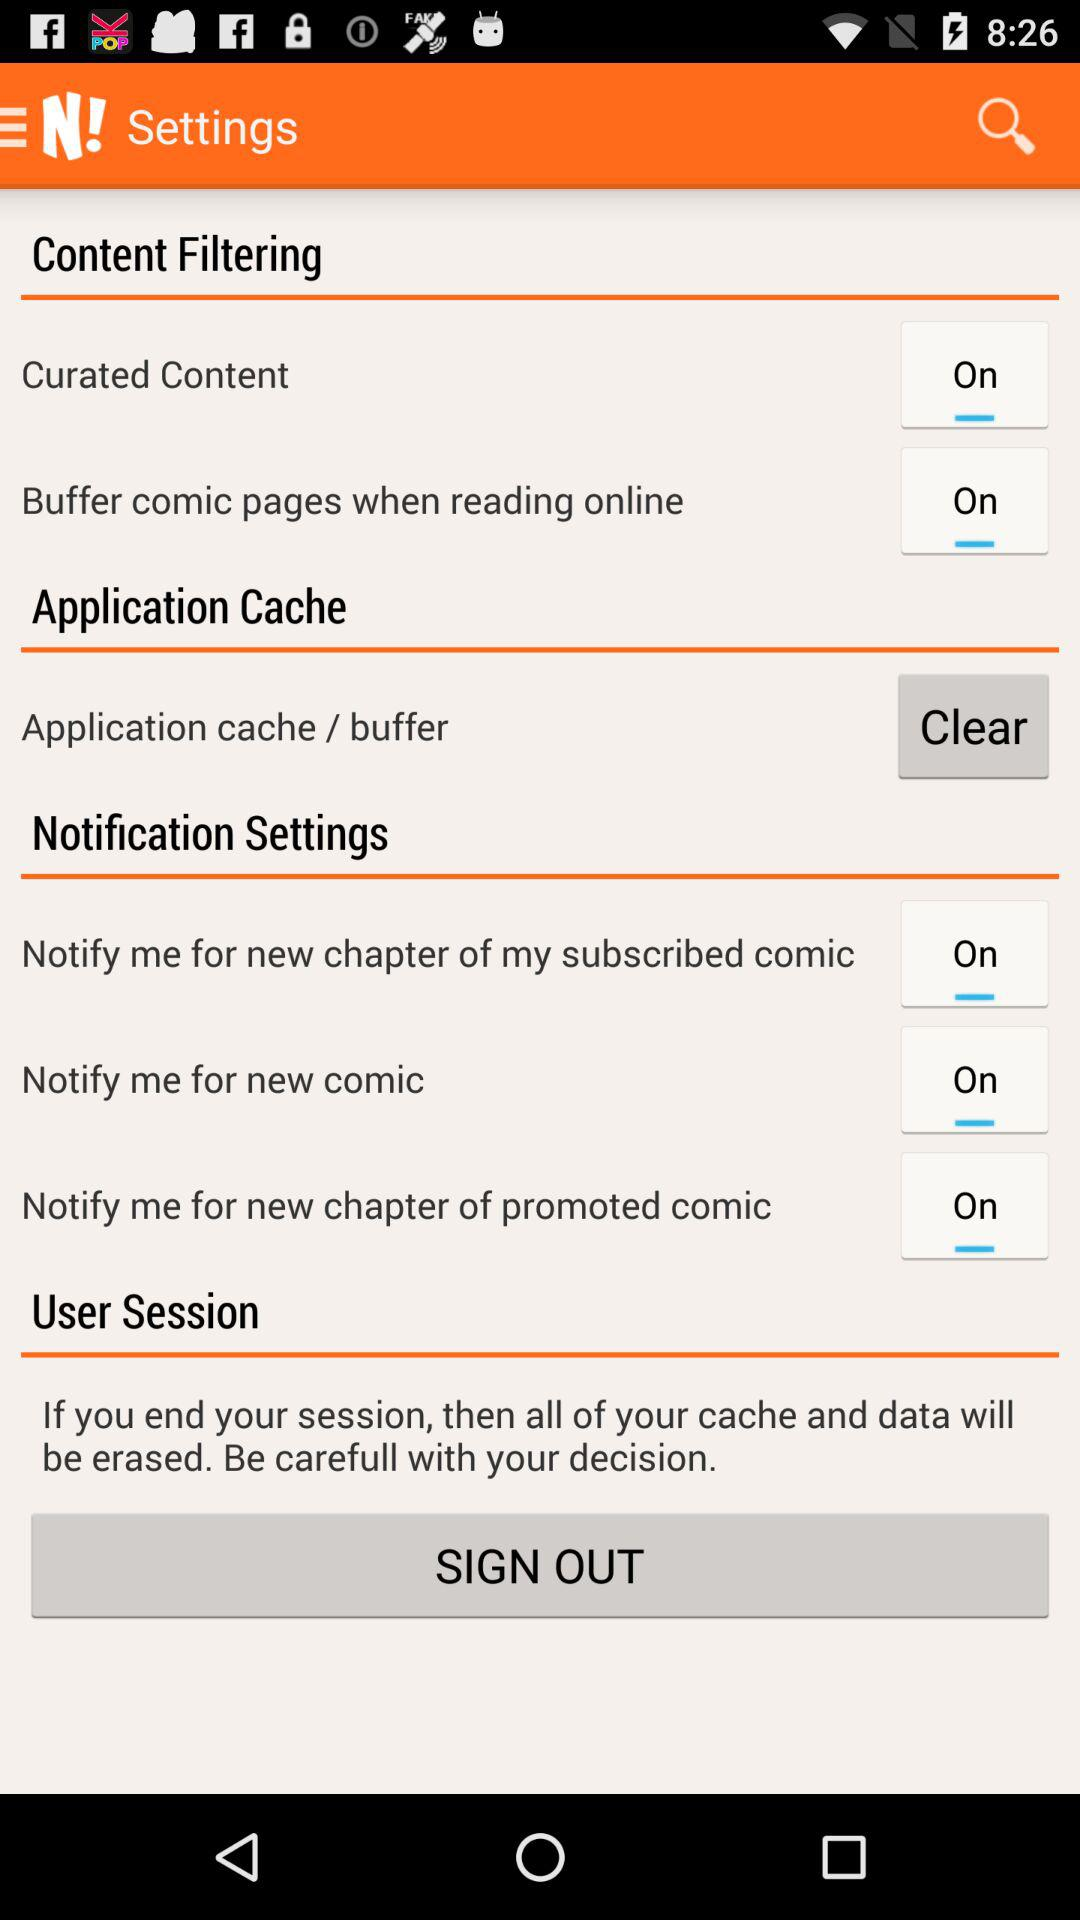Is "Notify me for new comic" on or off? "Notify me for new comic" is on. 